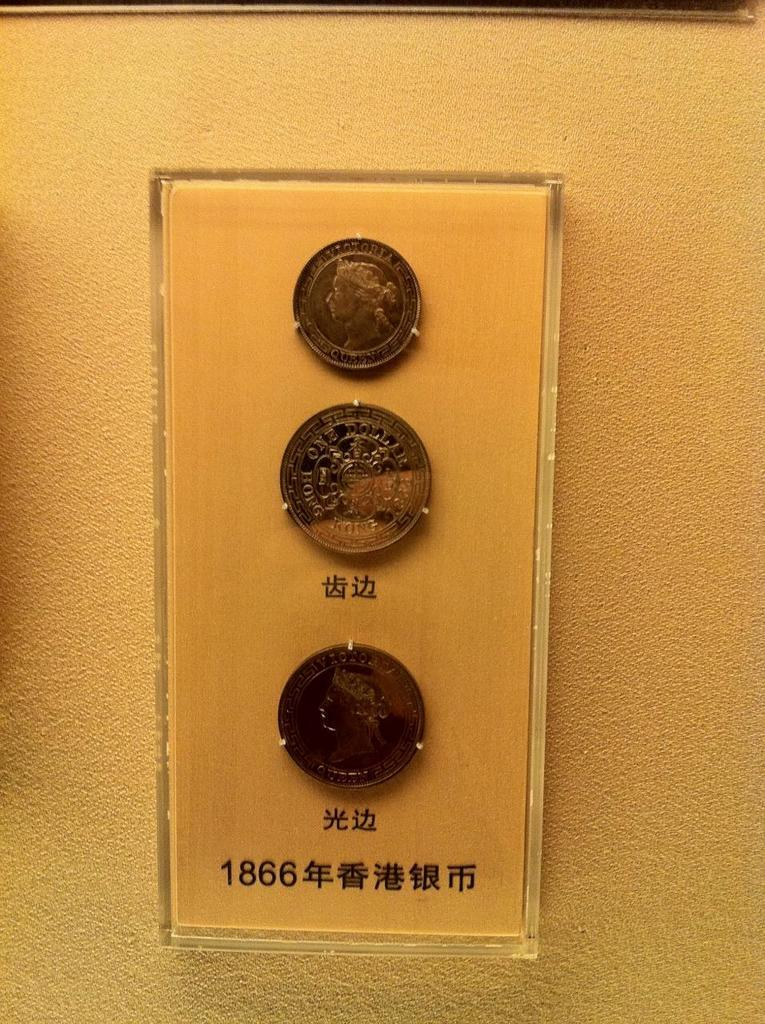<image>
Summarize the visual content of the image. Three coins are showcased in a glass case with the number 1866 at the bottom. 